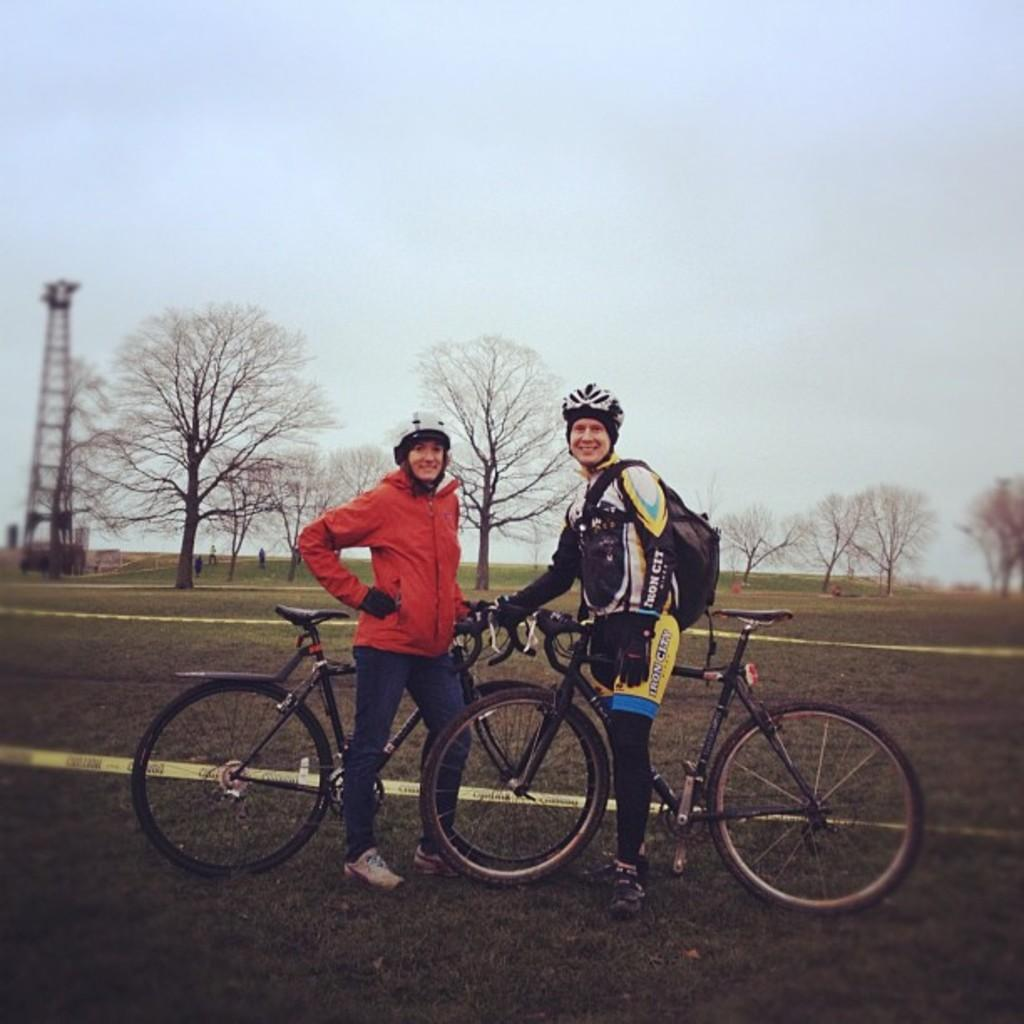How many people are in the image? There are two persons in the image. What are the persons doing in the image? The persons are beside a bicycle. Where is the bicycle located? The bicycle is on a grass field. What can be seen on the left side of the image? There is a tower on the left side of the image. How many ducks are swimming in the square in the image? There are no ducks or squares present in the image. Is there a bridge visible in the image? There is no bridge visible in the image. 